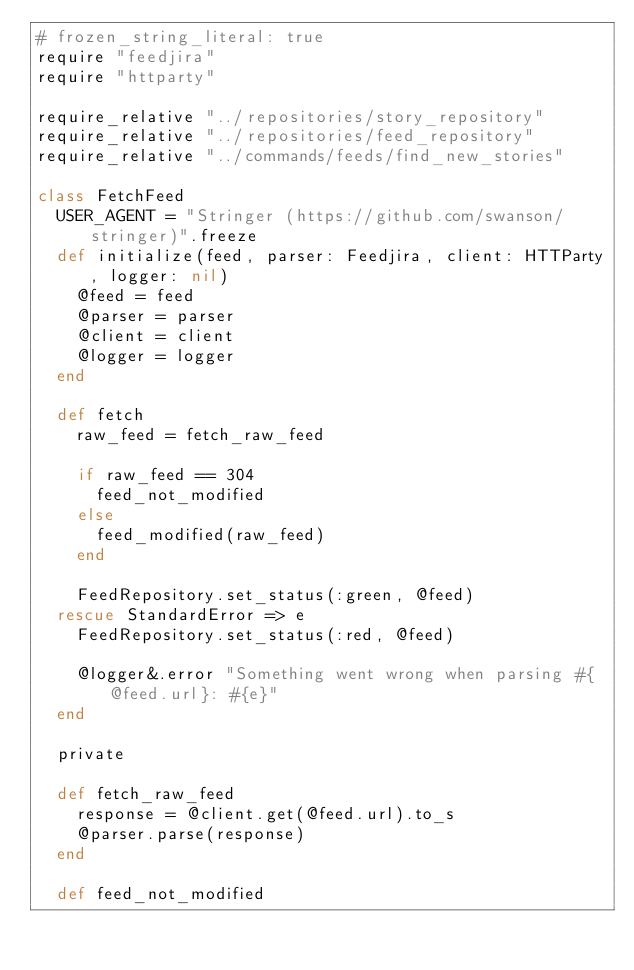<code> <loc_0><loc_0><loc_500><loc_500><_Ruby_># frozen_string_literal: true
require "feedjira"
require "httparty"

require_relative "../repositories/story_repository"
require_relative "../repositories/feed_repository"
require_relative "../commands/feeds/find_new_stories"

class FetchFeed
  USER_AGENT = "Stringer (https://github.com/swanson/stringer)".freeze
  def initialize(feed, parser: Feedjira, client: HTTParty, logger: nil)
    @feed = feed
    @parser = parser
    @client = client
    @logger = logger
  end

  def fetch
    raw_feed = fetch_raw_feed

    if raw_feed == 304
      feed_not_modified
    else
      feed_modified(raw_feed)
    end

    FeedRepository.set_status(:green, @feed)
  rescue StandardError => e
    FeedRepository.set_status(:red, @feed)

    @logger&.error "Something went wrong when parsing #{@feed.url}: #{e}"
  end

  private

  def fetch_raw_feed
    response = @client.get(@feed.url).to_s
    @parser.parse(response)
  end

  def feed_not_modified</code> 